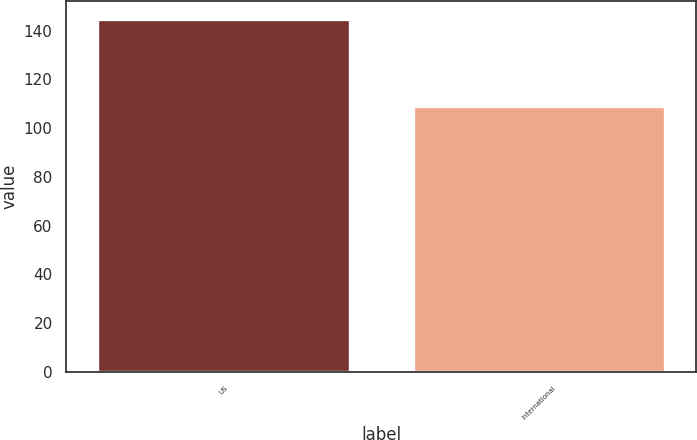Convert chart. <chart><loc_0><loc_0><loc_500><loc_500><bar_chart><fcel>US<fcel>International<nl><fcel>145<fcel>109<nl></chart> 